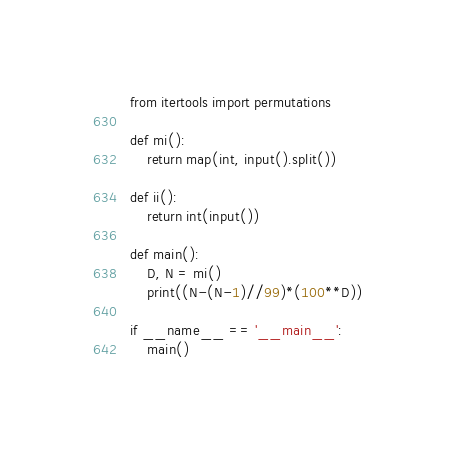<code> <loc_0><loc_0><loc_500><loc_500><_Python_>from itertools import permutations

def mi():
    return map(int, input().split())

def ii():
    return int(input())

def main():
    D, N = mi()
    print((N-(N-1)//99)*(100**D))

if __name__ == '__main__':
    main()</code> 